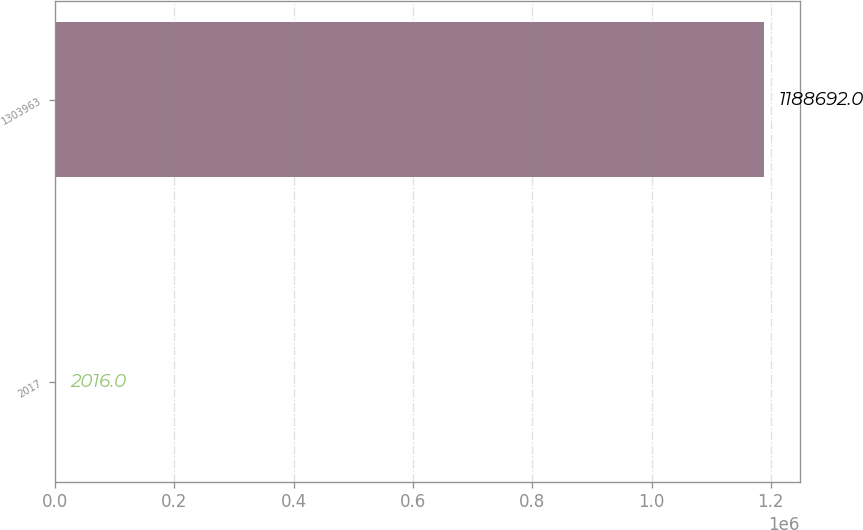Convert chart to OTSL. <chart><loc_0><loc_0><loc_500><loc_500><bar_chart><fcel>2017<fcel>1303963<nl><fcel>2016<fcel>1.18869e+06<nl></chart> 